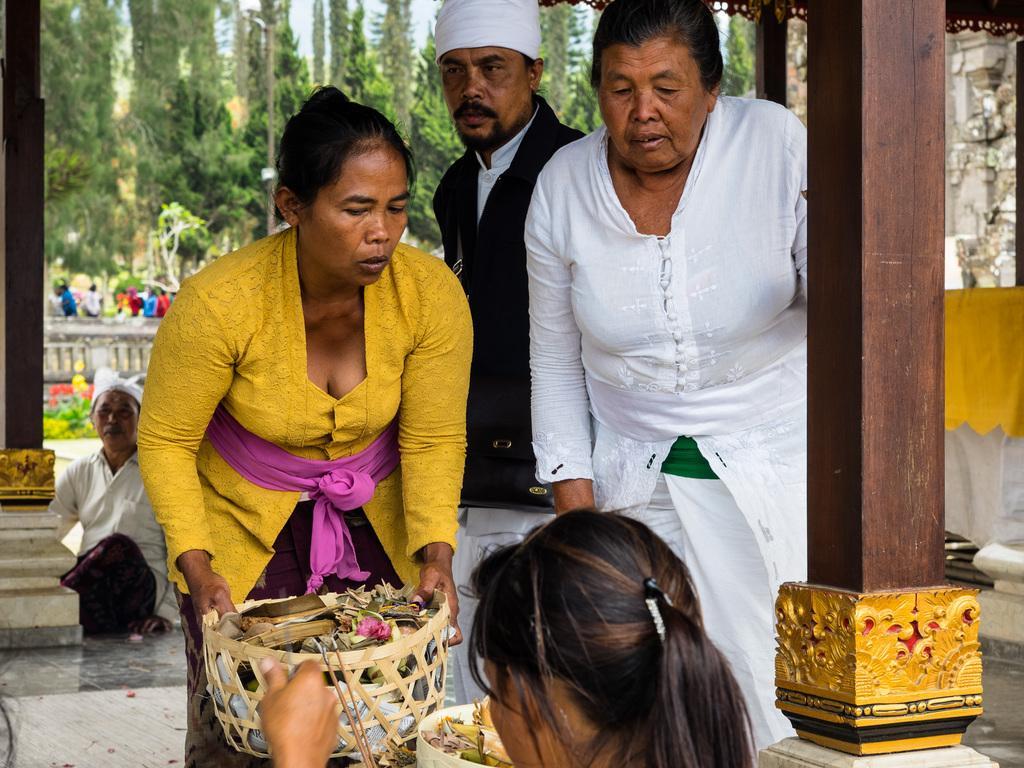Please provide a concise description of this image. In this image we can see few persons and among them a person is holding an object. There are few wooden pillars in the foreground. Behind the persons we can see a group of trees, persons and a wall. On the right side, we can see a wall. 